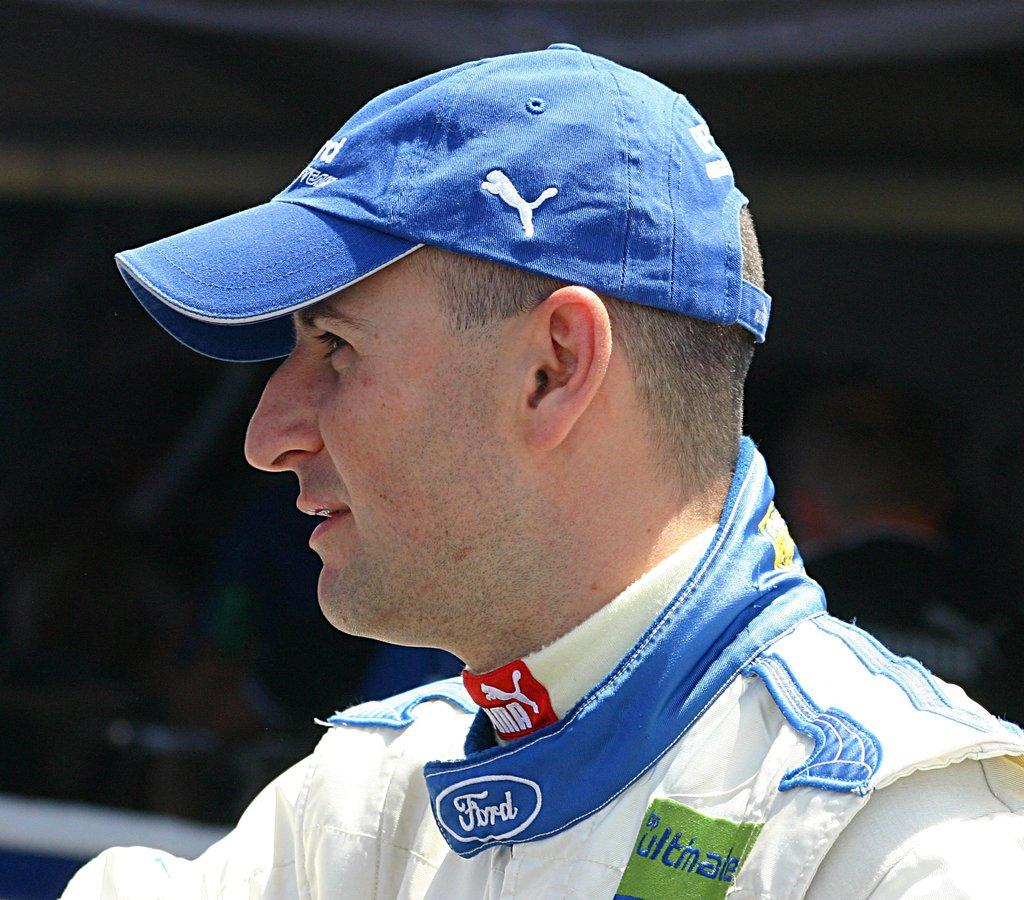<image>
Give a short and clear explanation of the subsequent image. the word Ford is on the collar of a man 